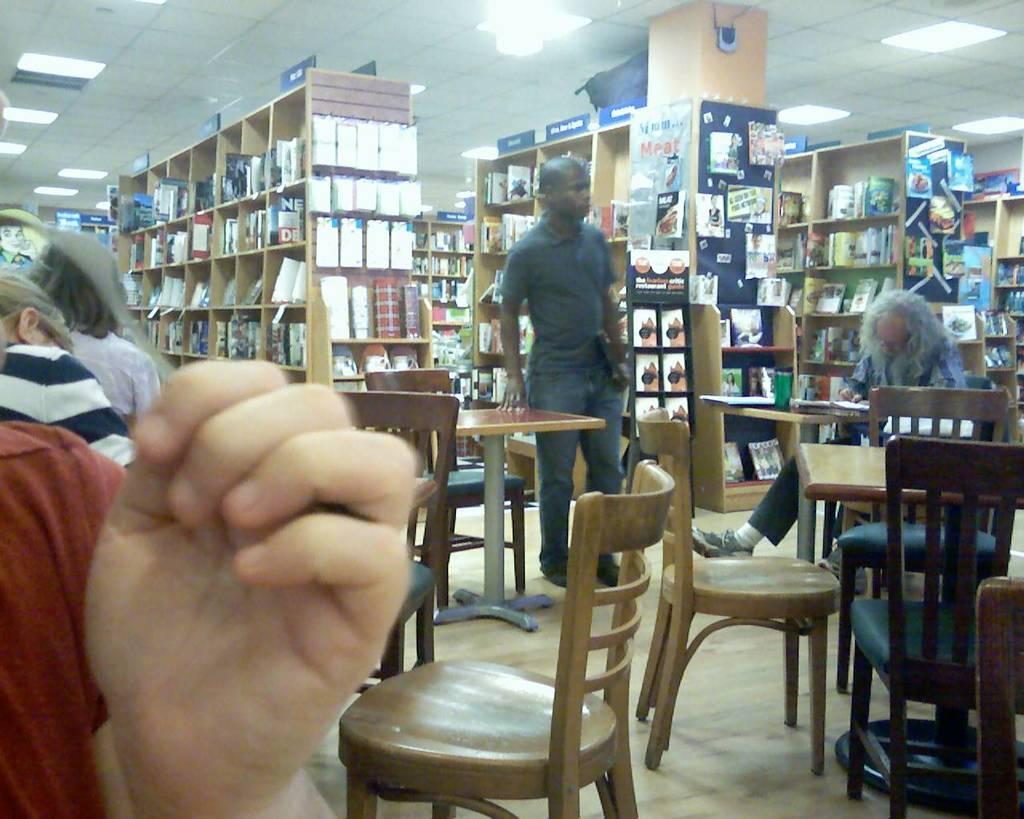Could you give a brief overview of what you see in this image? On the left we can see human hand and two persons were standing. On the right we can see one man sitting on chair around table. In the center there is a man standing and we can see table and few more empty chairs. In the background there is a shelf,books,camera,backpack,light etc, 